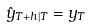Convert formula to latex. <formula><loc_0><loc_0><loc_500><loc_500>\hat { y } _ { T + h | T } = y _ { T }</formula> 